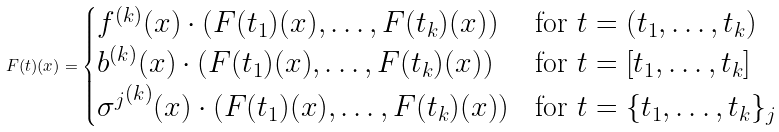<formula> <loc_0><loc_0><loc_500><loc_500>F ( t ) ( x ) = \begin{cases} f ^ { ( k ) } ( x ) \cdot ( F ( t _ { 1 } ) ( x ) , \dots , F ( t _ { k } ) ( x ) ) & \text {for } t = ( t _ { 1 } , \dots , t _ { k } ) \\ b ^ { ( k ) } ( x ) \cdot ( F ( t _ { 1 } ) ( x ) , \dots , F ( t _ { k } ) ( x ) ) & \text {for } t = [ t _ { 1 } , \dots , t _ { k } ] \\ { \sigma ^ { j } } ^ { ( k ) } ( x ) \cdot ( F ( t _ { 1 } ) ( x ) , \dots , F ( t _ { k } ) ( x ) ) & \text {for } t = \{ t _ { 1 } , \dots , t _ { k } \} _ { j } \end{cases}</formula> 